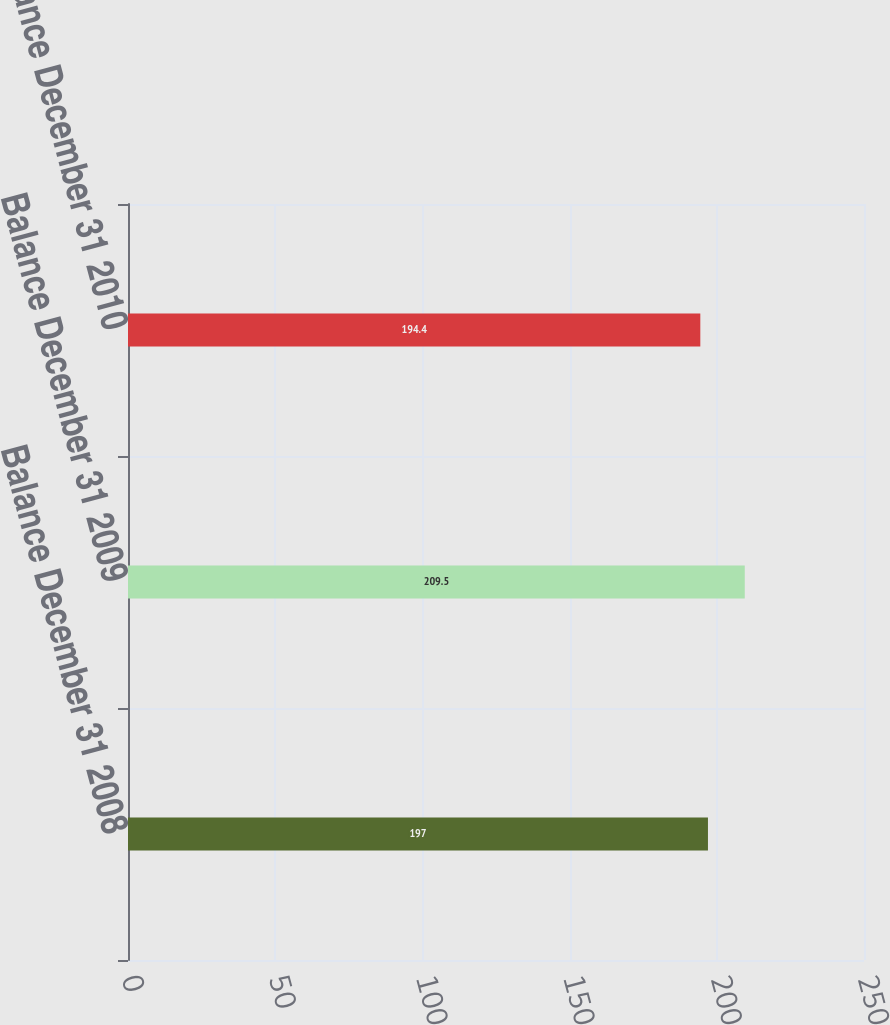<chart> <loc_0><loc_0><loc_500><loc_500><bar_chart><fcel>Balance December 31 2008<fcel>Balance December 31 2009<fcel>Balance December 31 2010<nl><fcel>197<fcel>209.5<fcel>194.4<nl></chart> 